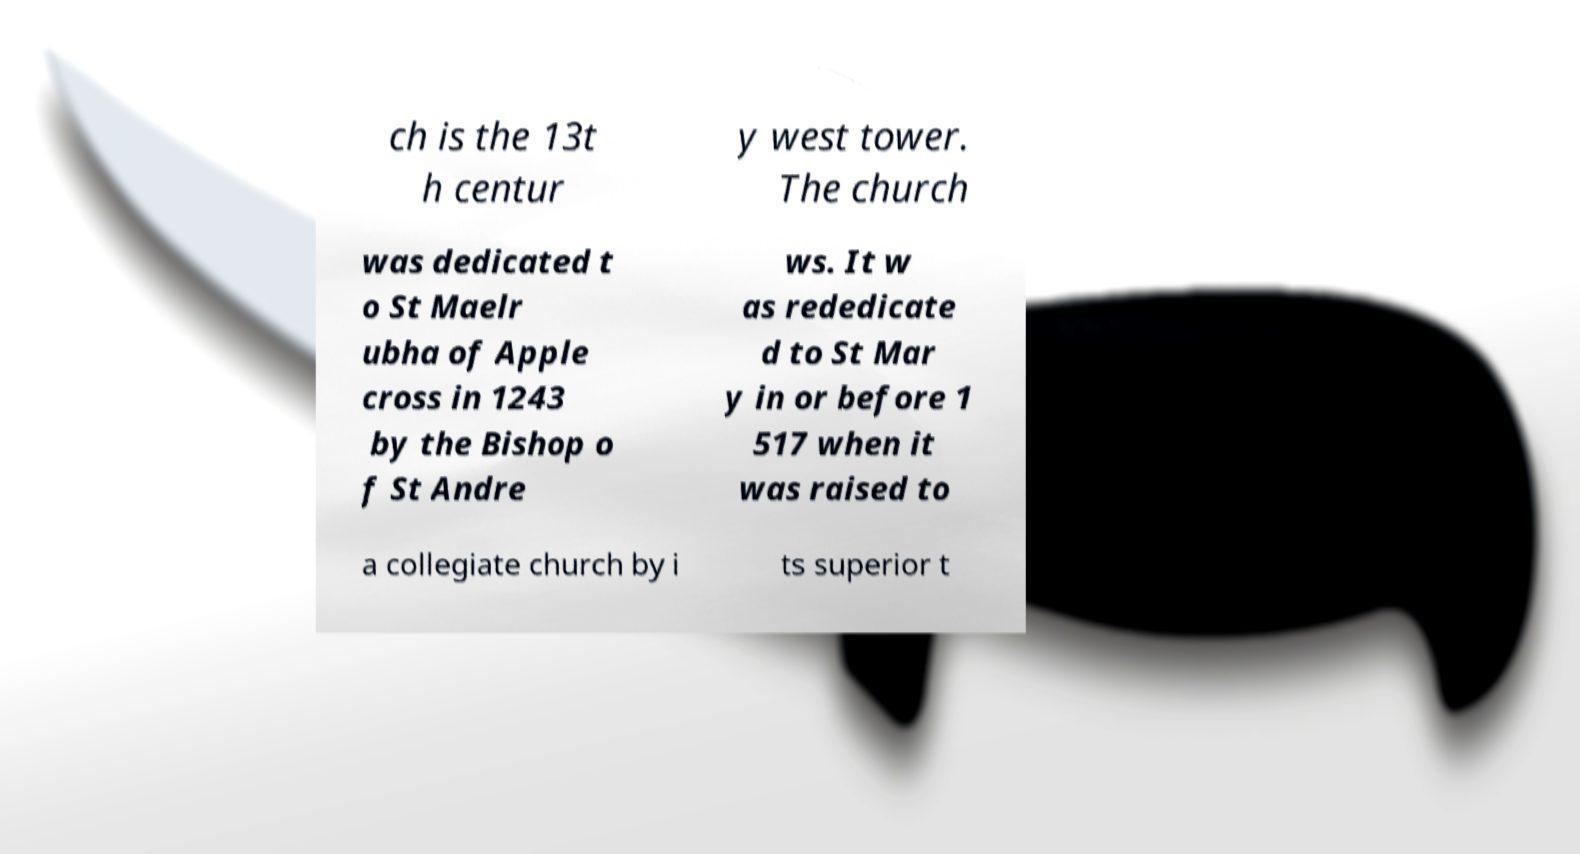Please read and relay the text visible in this image. What does it say? ch is the 13t h centur y west tower. The church was dedicated t o St Maelr ubha of Apple cross in 1243 by the Bishop o f St Andre ws. It w as rededicate d to St Mar y in or before 1 517 when it was raised to a collegiate church by i ts superior t 